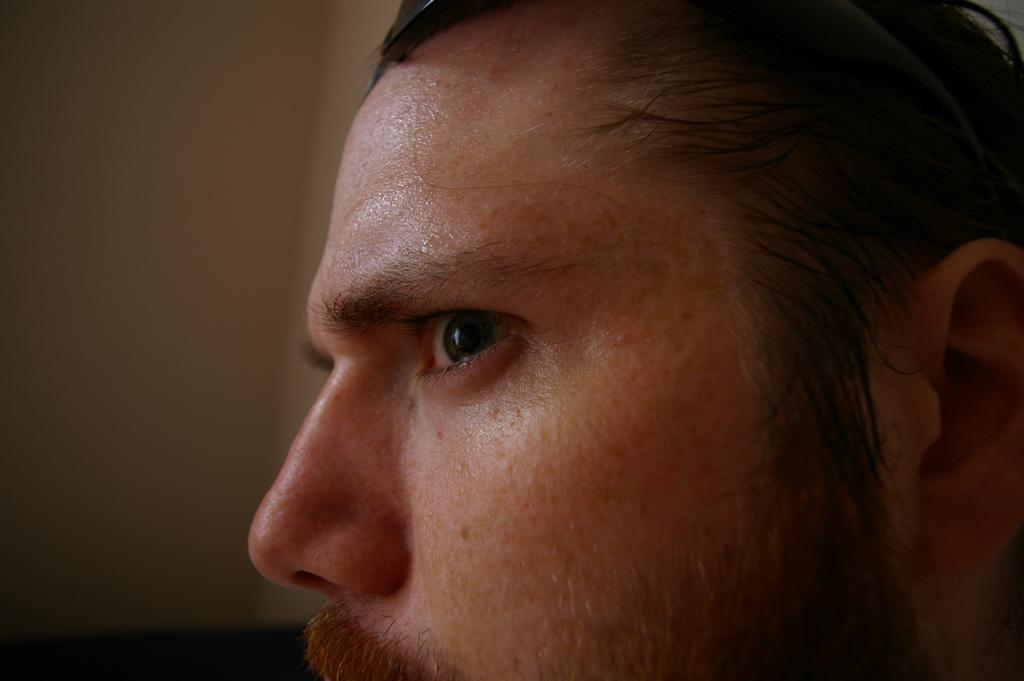What is present in the image? There is a person in the image. What can be seen behind the person? There is a wall in the image. Can you describe the setting where the image was taken? The image is likely taken in a room, given the presence of a wall. What type of drink is the person holding in the image? There is no drink visible in the image; the person is not holding anything. What type of company is the person representing in the image? There is no indication of any company affiliation in the image. 